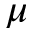<formula> <loc_0><loc_0><loc_500><loc_500>\mu</formula> 